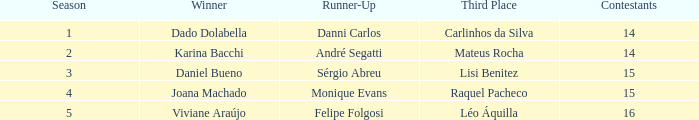When monique evans was the runner-up, how many participants were in the competition? 15.0. 